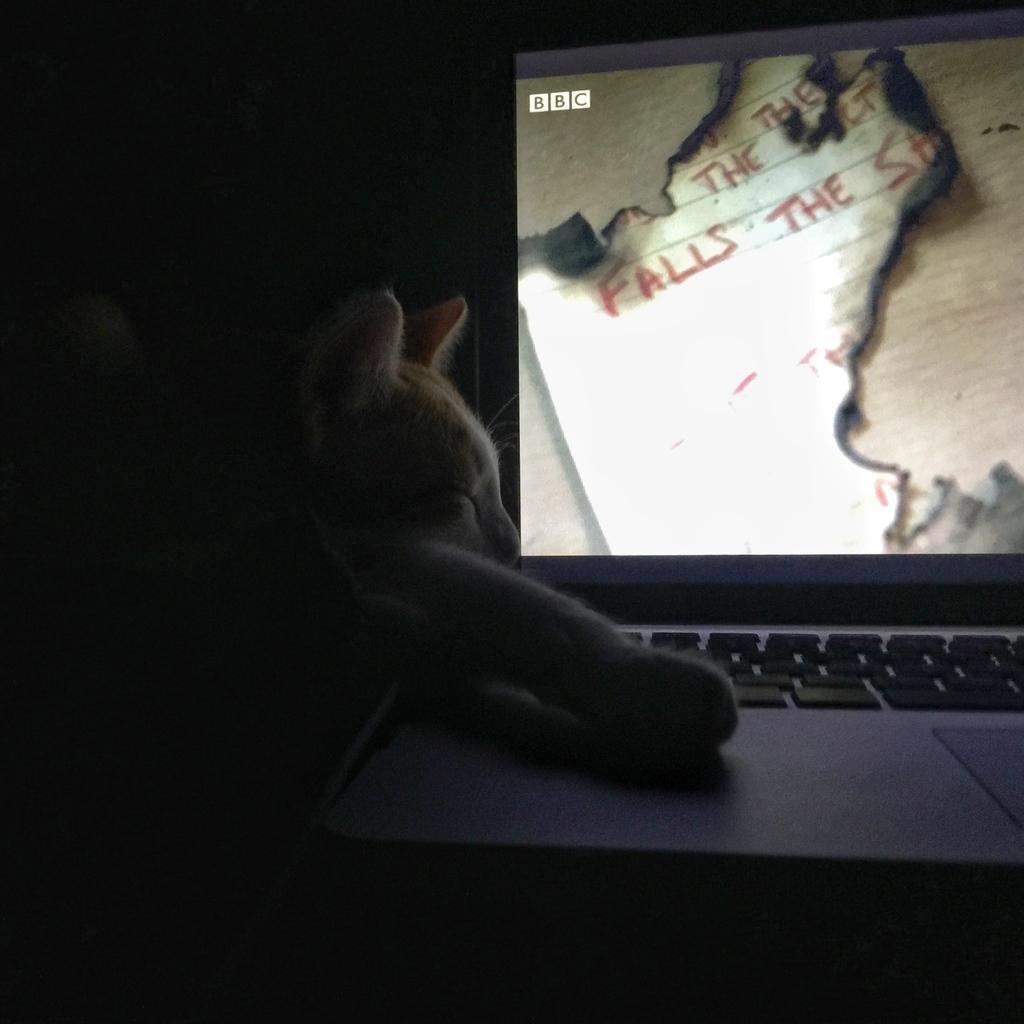How would you summarize this image in a sentence or two? In the picture we can see a laptop which is opened with a screen and keys on it and inside we can see a cat which is sleeping. 